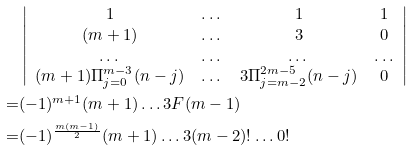<formula> <loc_0><loc_0><loc_500><loc_500>& \left | \begin{array} { c c c c } 1 & \dots & 1 & 1 \\ ( m + 1 ) & \dots & 3 & 0 \\ \dots & \dots & \dots & \dots \\ ( m + 1 ) \Pi _ { j = 0 } ^ { m - 3 } ( n - j ) & \dots & 3 \Pi _ { j = m - 2 } ^ { 2 m - 5 } ( n - j ) & 0 \end{array} \right | \\ = & ( - 1 ) ^ { m + 1 } ( m + 1 ) \dots 3 F ( m - 1 ) \\ = & ( - 1 ) ^ { \frac { m ( m - 1 ) } 2 } ( m + 1 ) \dots 3 ( m - 2 ) ! \dots 0 !</formula> 